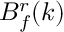Convert formula to latex. <formula><loc_0><loc_0><loc_500><loc_500>B _ { f } ^ { r } ( k )</formula> 